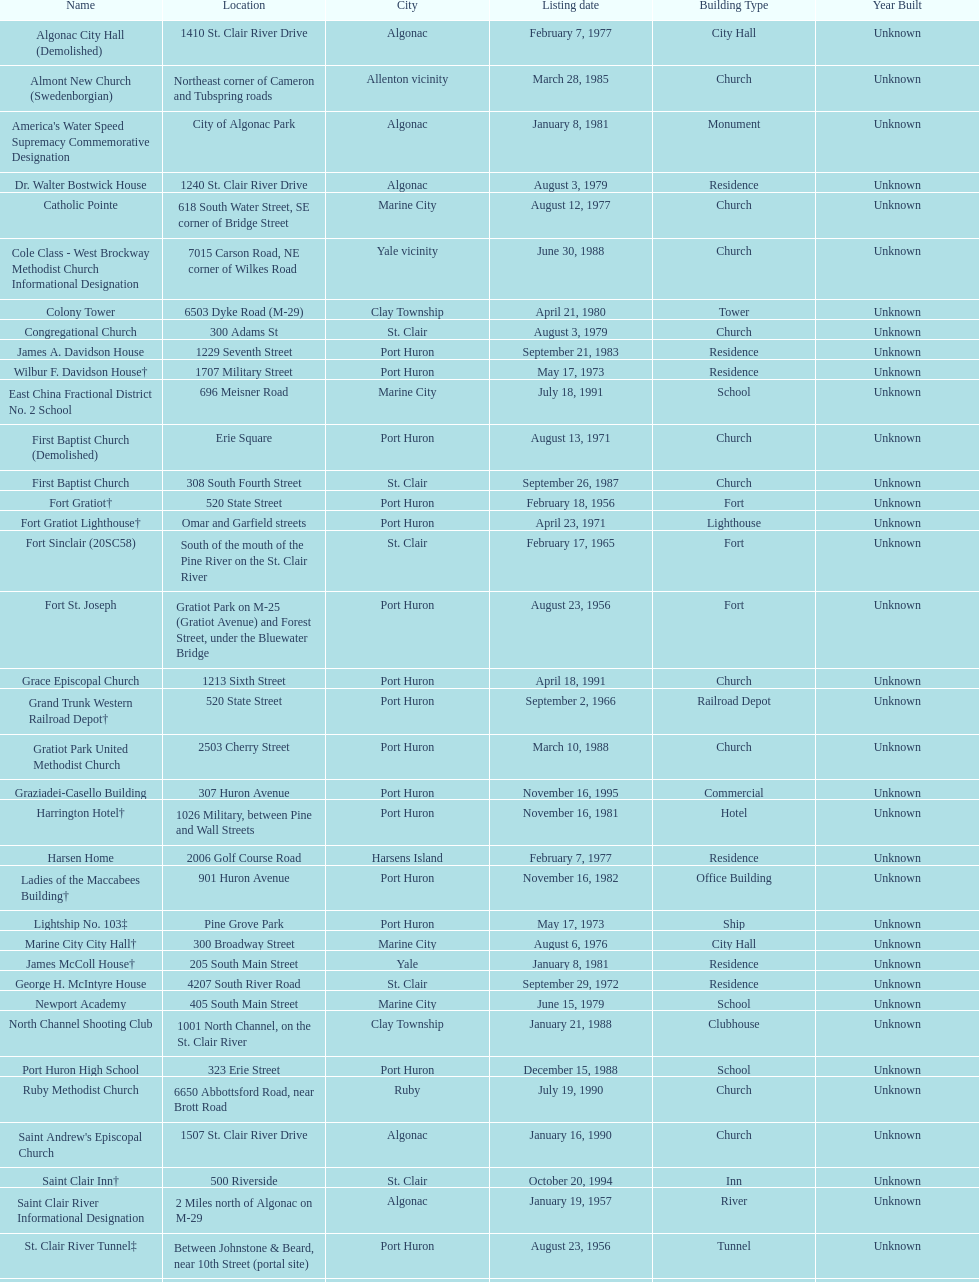What is the number of properties on the list that have been demolished? 2. 